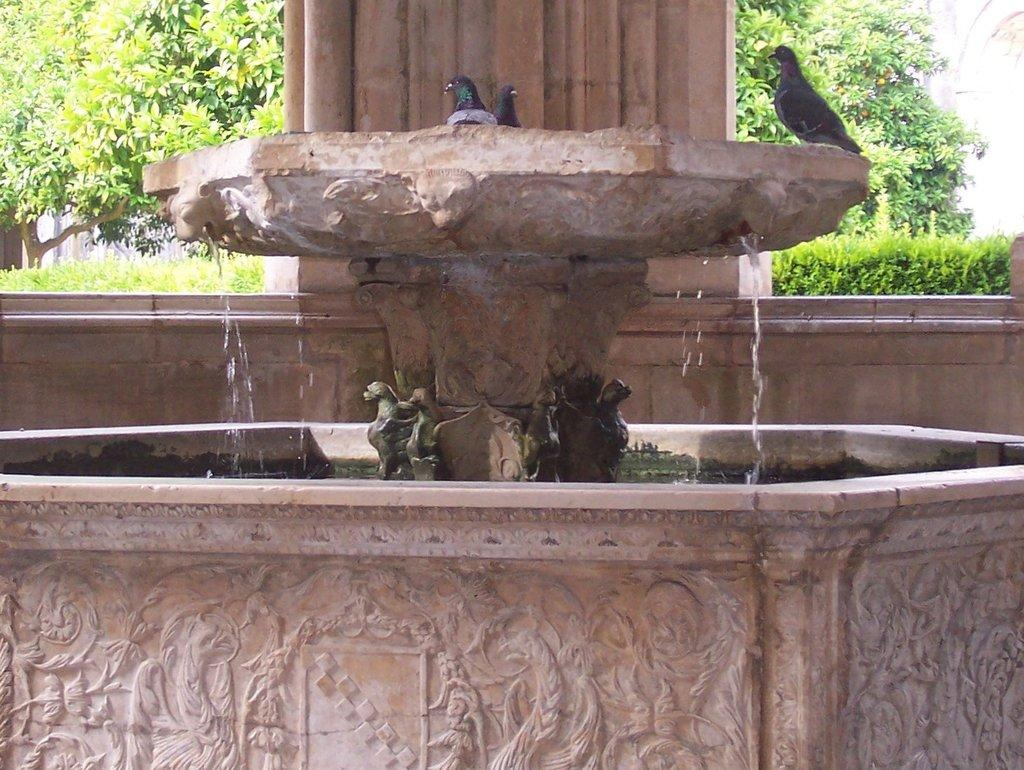What type of animals can be seen on the surface in the image? There are birds on the surface in the image. What is visible beneath the birds in the image? There is water visible in the image. What architectural feature can be seen in the image? There is a pillar in the image. What type of vegetation is visible in the background of the image? There are trees and bushes in the background of the image. What class of waves can be seen in the image? There are no waves present in the image; it features birds on the surface and water beneath them. 